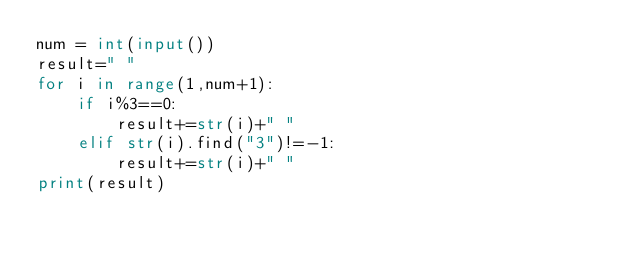<code> <loc_0><loc_0><loc_500><loc_500><_Python_>num = int(input())
result=" "
for i in range(1,num+1):
    if i%3==0:
        result+=str(i)+" "
    elif str(i).find("3")!=-1:
        result+=str(i)+" "
print(result)

</code> 